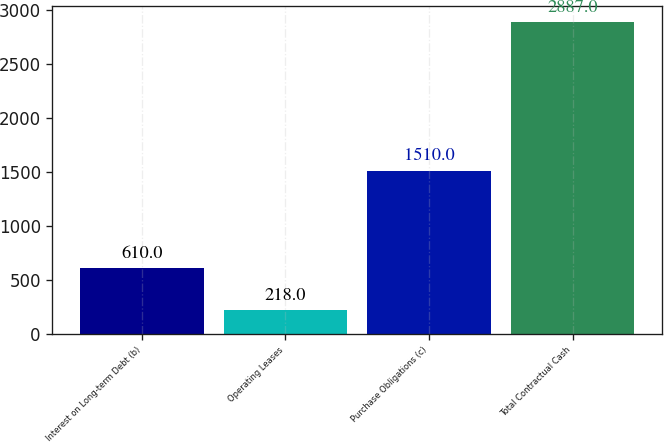<chart> <loc_0><loc_0><loc_500><loc_500><bar_chart><fcel>Interest on Long-term Debt (b)<fcel>Operating Leases<fcel>Purchase Obligations (c)<fcel>Total Contractual Cash<nl><fcel>610<fcel>218<fcel>1510<fcel>2887<nl></chart> 